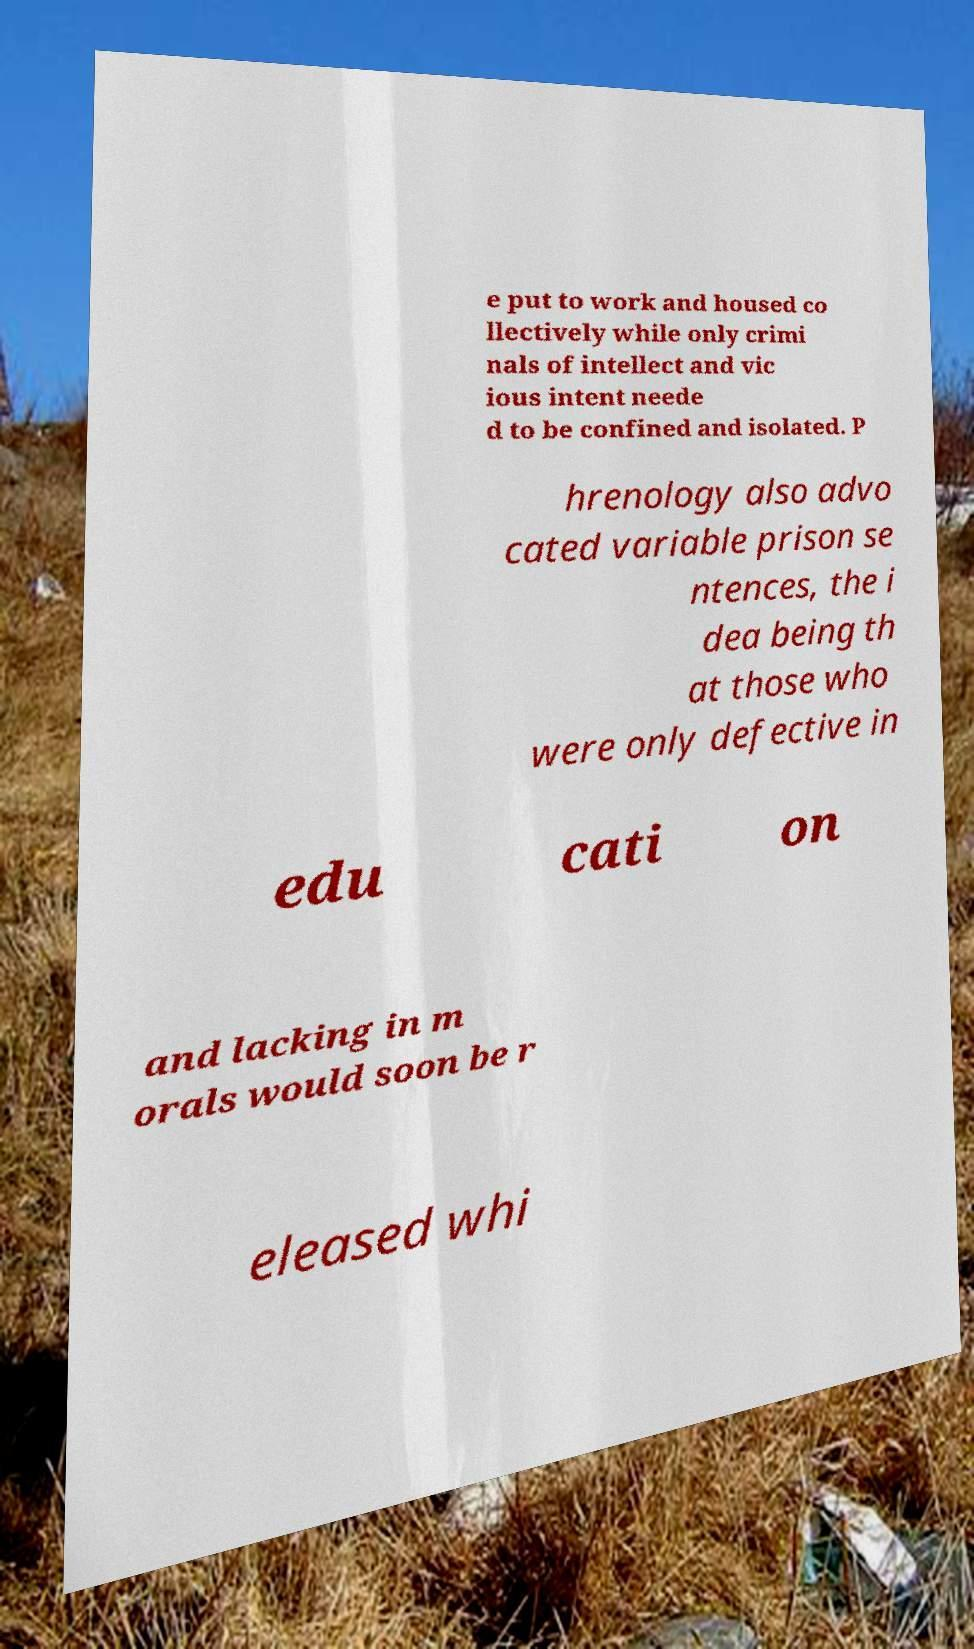Please identify and transcribe the text found in this image. e put to work and housed co llectively while only crimi nals of intellect and vic ious intent neede d to be confined and isolated. P hrenology also advo cated variable prison se ntences, the i dea being th at those who were only defective in edu cati on and lacking in m orals would soon be r eleased whi 